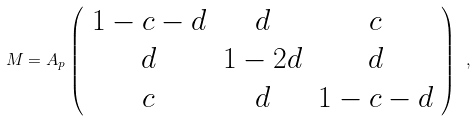Convert formula to latex. <formula><loc_0><loc_0><loc_500><loc_500>M = A _ { p } \left ( \begin{array} { c c c } 1 - c - d & d & c \\ d & 1 - 2 d & d \\ c & d & 1 - c - d \end{array} \right ) \ ,</formula> 